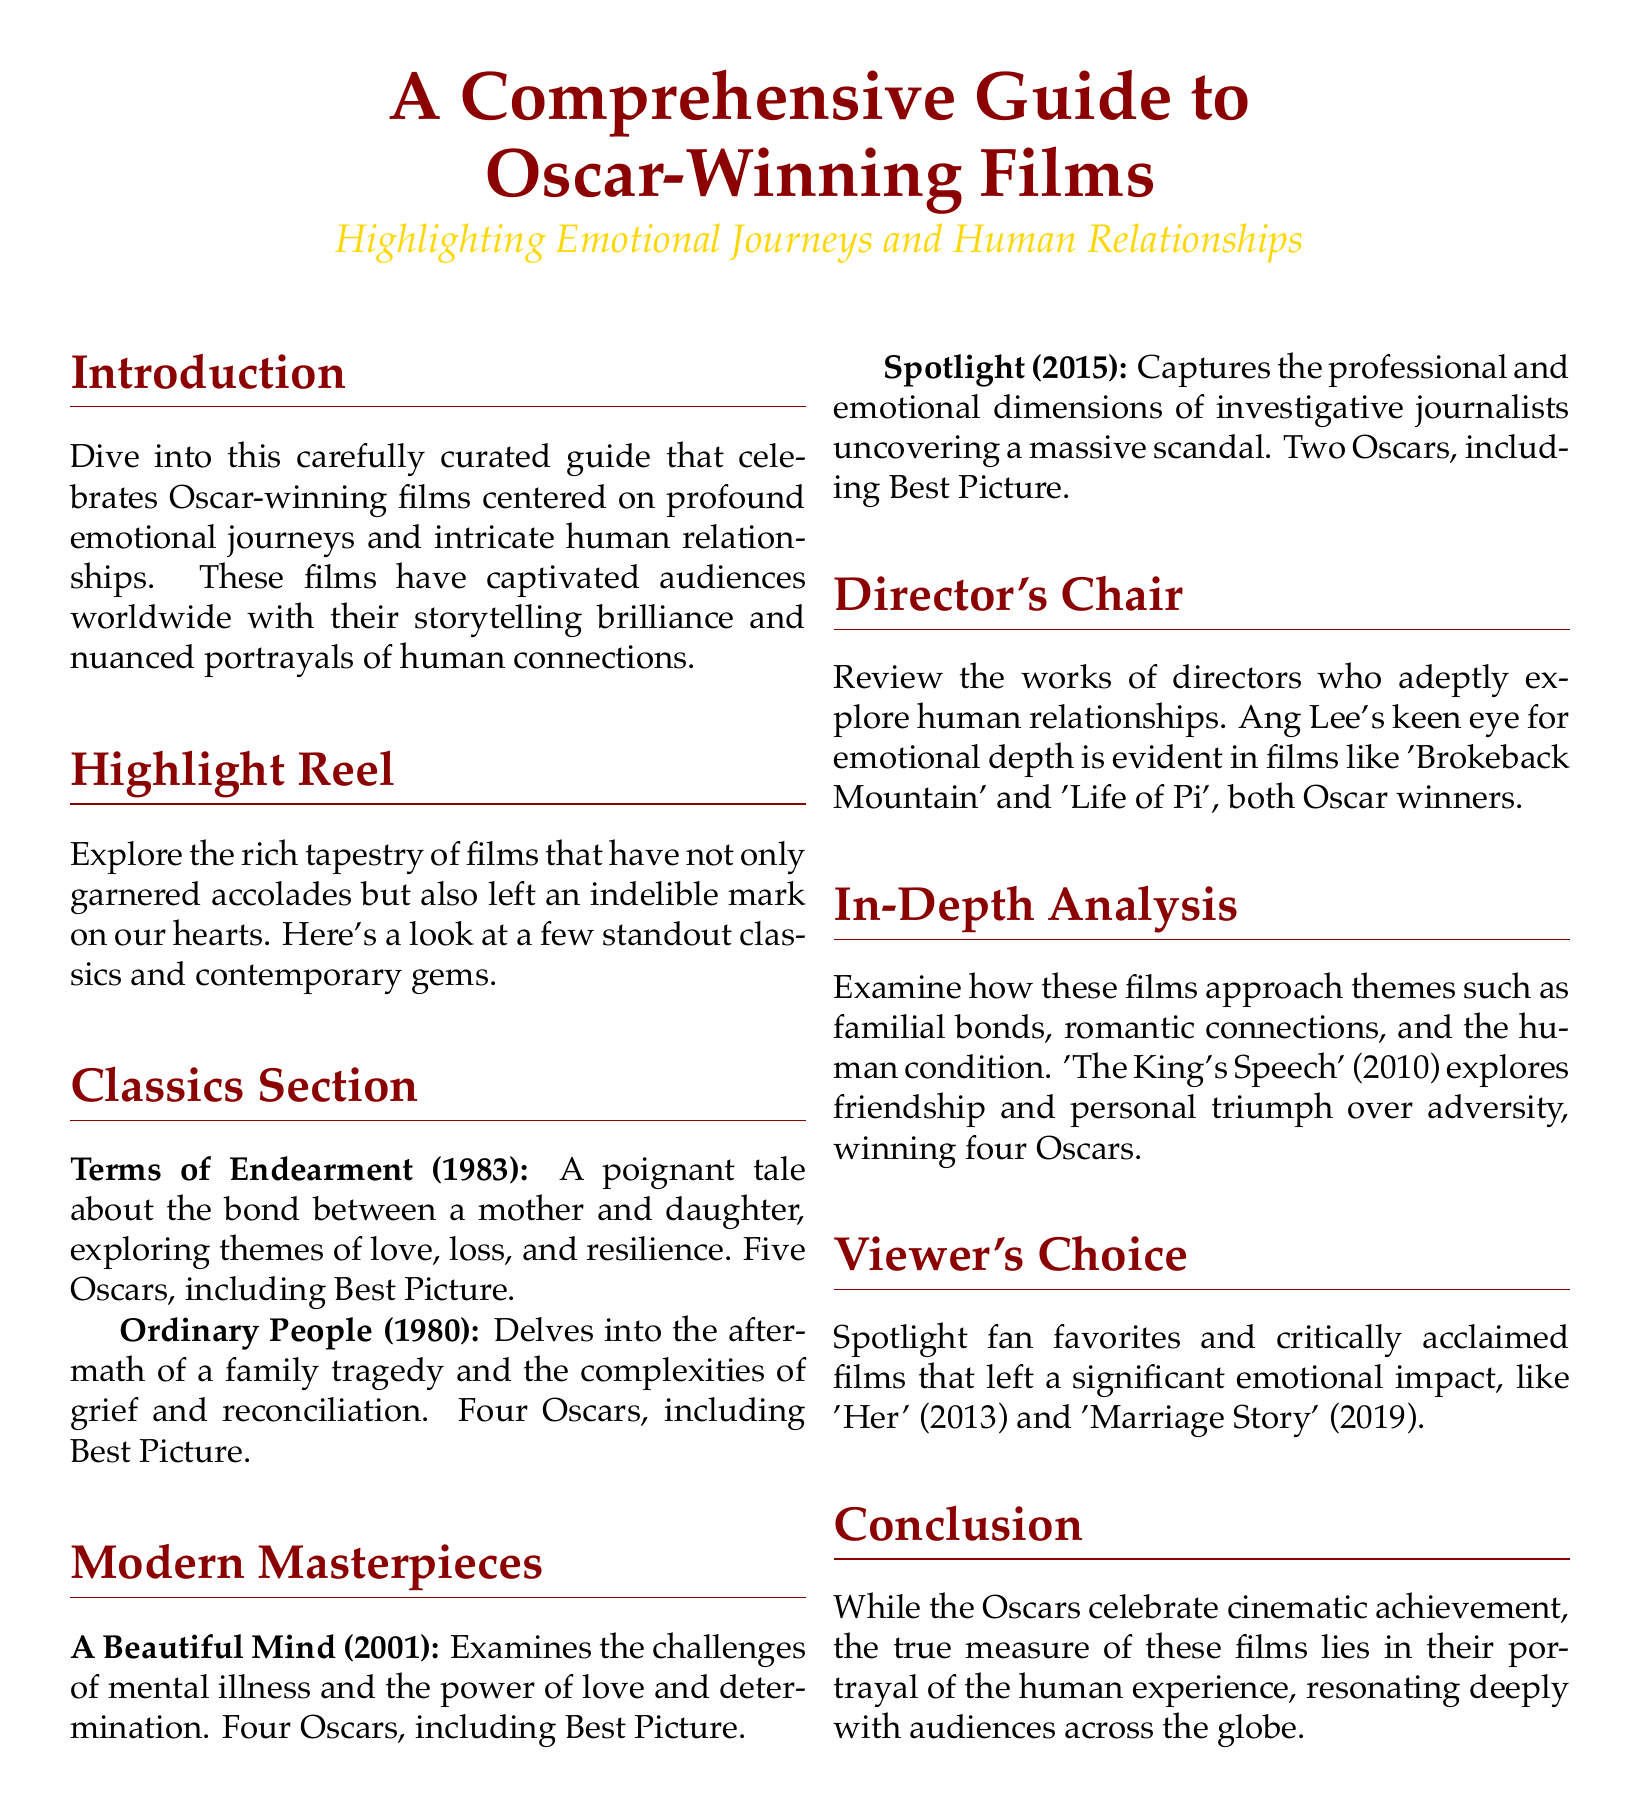What is the title of the guide? The title of the guide is presented prominently in the document's header.
Answer: A Comprehensive Guide to Oscar-Winning Films How many Oscars did 'Terms of Endearment' win? The document explicitly states the number of Oscars this film has won in the classics section.
Answer: Five Oscars What year was 'A Beautiful Mind' released? The release year of this film is mentioned in the modern masterpieces section of the document.
Answer: 2001 Which director is noted for exploring emotional depth in films? The document highlights a specific director known for his emotional storytelling abilities.
Answer: Ang Lee What theme does 'The King's Speech' explore? The document summarizes the themes that this film specifically addresses in the in-depth analysis section.
Answer: Friendship How many Oscars did 'Marriage Story' win? The document refers to this film's general acclaim but does not specify the number of Oscars.
Answer: Not specified What type of human connection does 'Ordinary People' focus on? The document describes the central themes of this film in the classics section.
Answer: Family tragedy What is a highlighted fan-favorite film mentioned? The document includes popular films that have had significant emotional impacts according to the viewer's choice section.
Answer: Her Which section discusses the aftermath of family tragedy? The section title provides insight into the content discussed concerning the emotional and human connection themes.
Answer: Classics Section 